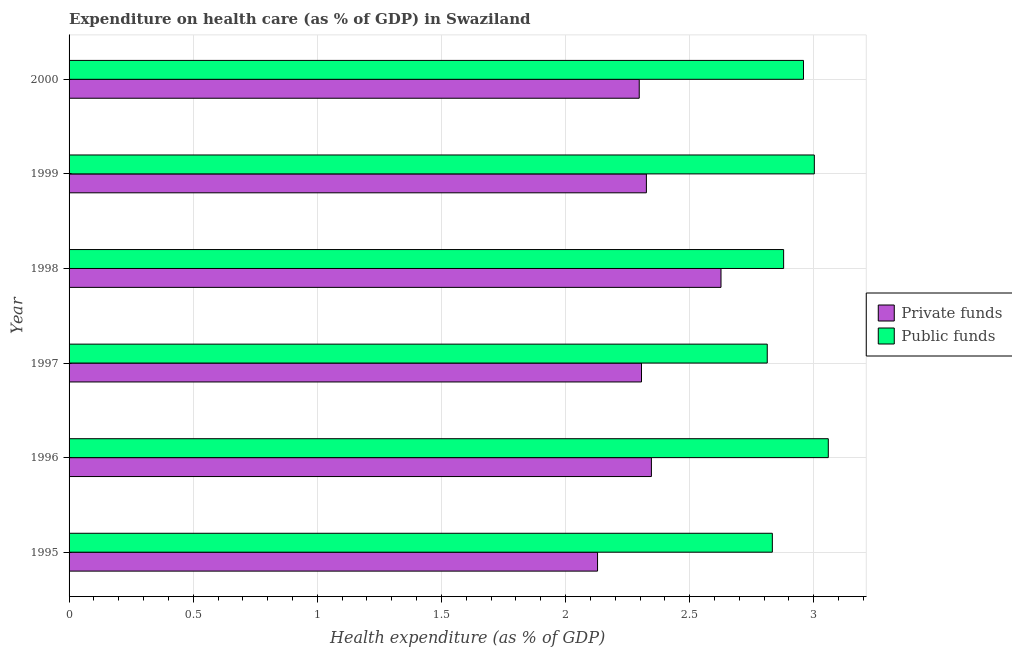Are the number of bars per tick equal to the number of legend labels?
Your response must be concise. Yes. Are the number of bars on each tick of the Y-axis equal?
Ensure brevity in your answer.  Yes. How many bars are there on the 5th tick from the bottom?
Ensure brevity in your answer.  2. What is the label of the 3rd group of bars from the top?
Your response must be concise. 1998. In how many cases, is the number of bars for a given year not equal to the number of legend labels?
Your response must be concise. 0. What is the amount of public funds spent in healthcare in 1998?
Offer a very short reply. 2.88. Across all years, what is the maximum amount of private funds spent in healthcare?
Provide a succinct answer. 2.63. Across all years, what is the minimum amount of public funds spent in healthcare?
Provide a succinct answer. 2.81. In which year was the amount of public funds spent in healthcare maximum?
Your response must be concise. 1996. In which year was the amount of public funds spent in healthcare minimum?
Provide a short and direct response. 1997. What is the total amount of public funds spent in healthcare in the graph?
Provide a short and direct response. 17.54. What is the difference between the amount of public funds spent in healthcare in 1997 and that in 2000?
Provide a short and direct response. -0.15. What is the difference between the amount of public funds spent in healthcare in 1995 and the amount of private funds spent in healthcare in 1998?
Your answer should be very brief. 0.21. What is the average amount of private funds spent in healthcare per year?
Provide a succinct answer. 2.34. In the year 2000, what is the difference between the amount of private funds spent in healthcare and amount of public funds spent in healthcare?
Offer a terse response. -0.66. In how many years, is the amount of public funds spent in healthcare greater than 2.8 %?
Your answer should be compact. 6. What is the ratio of the amount of public funds spent in healthcare in 1998 to that in 2000?
Provide a succinct answer. 0.97. What is the difference between the highest and the second highest amount of private funds spent in healthcare?
Offer a terse response. 0.28. In how many years, is the amount of public funds spent in healthcare greater than the average amount of public funds spent in healthcare taken over all years?
Ensure brevity in your answer.  3. Is the sum of the amount of public funds spent in healthcare in 1998 and 2000 greater than the maximum amount of private funds spent in healthcare across all years?
Offer a terse response. Yes. What does the 2nd bar from the top in 2000 represents?
Your response must be concise. Private funds. What does the 2nd bar from the bottom in 1999 represents?
Keep it short and to the point. Public funds. How many bars are there?
Your answer should be compact. 12. Are all the bars in the graph horizontal?
Provide a short and direct response. Yes. What is the difference between two consecutive major ticks on the X-axis?
Give a very brief answer. 0.5. Are the values on the major ticks of X-axis written in scientific E-notation?
Your answer should be very brief. No. Does the graph contain any zero values?
Make the answer very short. No. How are the legend labels stacked?
Your answer should be compact. Vertical. What is the title of the graph?
Your answer should be very brief. Expenditure on health care (as % of GDP) in Swaziland. What is the label or title of the X-axis?
Ensure brevity in your answer.  Health expenditure (as % of GDP). What is the Health expenditure (as % of GDP) in Private funds in 1995?
Offer a very short reply. 2.13. What is the Health expenditure (as % of GDP) of Public funds in 1995?
Give a very brief answer. 2.83. What is the Health expenditure (as % of GDP) in Private funds in 1996?
Your answer should be very brief. 2.35. What is the Health expenditure (as % of GDP) in Public funds in 1996?
Make the answer very short. 3.06. What is the Health expenditure (as % of GDP) in Private funds in 1997?
Make the answer very short. 2.31. What is the Health expenditure (as % of GDP) in Public funds in 1997?
Offer a terse response. 2.81. What is the Health expenditure (as % of GDP) of Private funds in 1998?
Your answer should be compact. 2.63. What is the Health expenditure (as % of GDP) of Public funds in 1998?
Provide a succinct answer. 2.88. What is the Health expenditure (as % of GDP) in Private funds in 1999?
Give a very brief answer. 2.33. What is the Health expenditure (as % of GDP) in Public funds in 1999?
Offer a very short reply. 3. What is the Health expenditure (as % of GDP) of Private funds in 2000?
Offer a terse response. 2.3. What is the Health expenditure (as % of GDP) of Public funds in 2000?
Offer a very short reply. 2.96. Across all years, what is the maximum Health expenditure (as % of GDP) of Private funds?
Your answer should be compact. 2.63. Across all years, what is the maximum Health expenditure (as % of GDP) in Public funds?
Offer a very short reply. 3.06. Across all years, what is the minimum Health expenditure (as % of GDP) in Private funds?
Keep it short and to the point. 2.13. Across all years, what is the minimum Health expenditure (as % of GDP) in Public funds?
Provide a succinct answer. 2.81. What is the total Health expenditure (as % of GDP) in Private funds in the graph?
Your answer should be very brief. 14.03. What is the total Health expenditure (as % of GDP) of Public funds in the graph?
Provide a succinct answer. 17.54. What is the difference between the Health expenditure (as % of GDP) of Private funds in 1995 and that in 1996?
Offer a very short reply. -0.22. What is the difference between the Health expenditure (as % of GDP) of Public funds in 1995 and that in 1996?
Give a very brief answer. -0.23. What is the difference between the Health expenditure (as % of GDP) of Private funds in 1995 and that in 1997?
Provide a succinct answer. -0.18. What is the difference between the Health expenditure (as % of GDP) in Public funds in 1995 and that in 1997?
Your response must be concise. 0.02. What is the difference between the Health expenditure (as % of GDP) of Private funds in 1995 and that in 1998?
Provide a succinct answer. -0.5. What is the difference between the Health expenditure (as % of GDP) of Public funds in 1995 and that in 1998?
Make the answer very short. -0.05. What is the difference between the Health expenditure (as % of GDP) of Private funds in 1995 and that in 1999?
Provide a short and direct response. -0.2. What is the difference between the Health expenditure (as % of GDP) in Public funds in 1995 and that in 1999?
Give a very brief answer. -0.17. What is the difference between the Health expenditure (as % of GDP) of Private funds in 1995 and that in 2000?
Provide a succinct answer. -0.17. What is the difference between the Health expenditure (as % of GDP) of Public funds in 1995 and that in 2000?
Ensure brevity in your answer.  -0.13. What is the difference between the Health expenditure (as % of GDP) of Private funds in 1996 and that in 1997?
Provide a succinct answer. 0.04. What is the difference between the Health expenditure (as % of GDP) of Public funds in 1996 and that in 1997?
Keep it short and to the point. 0.25. What is the difference between the Health expenditure (as % of GDP) of Private funds in 1996 and that in 1998?
Make the answer very short. -0.28. What is the difference between the Health expenditure (as % of GDP) of Public funds in 1996 and that in 1998?
Make the answer very short. 0.18. What is the difference between the Health expenditure (as % of GDP) in Private funds in 1996 and that in 1999?
Your answer should be compact. 0.02. What is the difference between the Health expenditure (as % of GDP) in Public funds in 1996 and that in 1999?
Ensure brevity in your answer.  0.06. What is the difference between the Health expenditure (as % of GDP) of Private funds in 1996 and that in 2000?
Your response must be concise. 0.05. What is the difference between the Health expenditure (as % of GDP) in Private funds in 1997 and that in 1998?
Your answer should be very brief. -0.32. What is the difference between the Health expenditure (as % of GDP) of Public funds in 1997 and that in 1998?
Ensure brevity in your answer.  -0.07. What is the difference between the Health expenditure (as % of GDP) of Private funds in 1997 and that in 1999?
Keep it short and to the point. -0.02. What is the difference between the Health expenditure (as % of GDP) of Public funds in 1997 and that in 1999?
Your answer should be compact. -0.19. What is the difference between the Health expenditure (as % of GDP) of Private funds in 1997 and that in 2000?
Provide a short and direct response. 0.01. What is the difference between the Health expenditure (as % of GDP) of Public funds in 1997 and that in 2000?
Provide a short and direct response. -0.15. What is the difference between the Health expenditure (as % of GDP) of Private funds in 1998 and that in 1999?
Your response must be concise. 0.3. What is the difference between the Health expenditure (as % of GDP) of Public funds in 1998 and that in 1999?
Offer a terse response. -0.12. What is the difference between the Health expenditure (as % of GDP) in Private funds in 1998 and that in 2000?
Provide a short and direct response. 0.33. What is the difference between the Health expenditure (as % of GDP) of Public funds in 1998 and that in 2000?
Offer a very short reply. -0.08. What is the difference between the Health expenditure (as % of GDP) in Private funds in 1999 and that in 2000?
Your response must be concise. 0.03. What is the difference between the Health expenditure (as % of GDP) of Public funds in 1999 and that in 2000?
Offer a very short reply. 0.04. What is the difference between the Health expenditure (as % of GDP) in Private funds in 1995 and the Health expenditure (as % of GDP) in Public funds in 1996?
Offer a terse response. -0.93. What is the difference between the Health expenditure (as % of GDP) in Private funds in 1995 and the Health expenditure (as % of GDP) in Public funds in 1997?
Offer a terse response. -0.68. What is the difference between the Health expenditure (as % of GDP) of Private funds in 1995 and the Health expenditure (as % of GDP) of Public funds in 1998?
Your answer should be compact. -0.75. What is the difference between the Health expenditure (as % of GDP) in Private funds in 1995 and the Health expenditure (as % of GDP) in Public funds in 1999?
Make the answer very short. -0.87. What is the difference between the Health expenditure (as % of GDP) of Private funds in 1995 and the Health expenditure (as % of GDP) of Public funds in 2000?
Keep it short and to the point. -0.83. What is the difference between the Health expenditure (as % of GDP) of Private funds in 1996 and the Health expenditure (as % of GDP) of Public funds in 1997?
Offer a very short reply. -0.47. What is the difference between the Health expenditure (as % of GDP) in Private funds in 1996 and the Health expenditure (as % of GDP) in Public funds in 1998?
Your answer should be very brief. -0.53. What is the difference between the Health expenditure (as % of GDP) of Private funds in 1996 and the Health expenditure (as % of GDP) of Public funds in 1999?
Give a very brief answer. -0.66. What is the difference between the Health expenditure (as % of GDP) of Private funds in 1996 and the Health expenditure (as % of GDP) of Public funds in 2000?
Offer a very short reply. -0.61. What is the difference between the Health expenditure (as % of GDP) of Private funds in 1997 and the Health expenditure (as % of GDP) of Public funds in 1998?
Your response must be concise. -0.57. What is the difference between the Health expenditure (as % of GDP) in Private funds in 1997 and the Health expenditure (as % of GDP) in Public funds in 1999?
Offer a very short reply. -0.7. What is the difference between the Health expenditure (as % of GDP) of Private funds in 1997 and the Health expenditure (as % of GDP) of Public funds in 2000?
Give a very brief answer. -0.65. What is the difference between the Health expenditure (as % of GDP) of Private funds in 1998 and the Health expenditure (as % of GDP) of Public funds in 1999?
Your response must be concise. -0.38. What is the difference between the Health expenditure (as % of GDP) of Private funds in 1998 and the Health expenditure (as % of GDP) of Public funds in 2000?
Your answer should be very brief. -0.33. What is the difference between the Health expenditure (as % of GDP) of Private funds in 1999 and the Health expenditure (as % of GDP) of Public funds in 2000?
Offer a terse response. -0.63. What is the average Health expenditure (as % of GDP) in Private funds per year?
Keep it short and to the point. 2.34. What is the average Health expenditure (as % of GDP) in Public funds per year?
Give a very brief answer. 2.92. In the year 1995, what is the difference between the Health expenditure (as % of GDP) of Private funds and Health expenditure (as % of GDP) of Public funds?
Offer a very short reply. -0.7. In the year 1996, what is the difference between the Health expenditure (as % of GDP) in Private funds and Health expenditure (as % of GDP) in Public funds?
Your answer should be compact. -0.71. In the year 1997, what is the difference between the Health expenditure (as % of GDP) of Private funds and Health expenditure (as % of GDP) of Public funds?
Provide a succinct answer. -0.51. In the year 1998, what is the difference between the Health expenditure (as % of GDP) in Private funds and Health expenditure (as % of GDP) in Public funds?
Keep it short and to the point. -0.25. In the year 1999, what is the difference between the Health expenditure (as % of GDP) of Private funds and Health expenditure (as % of GDP) of Public funds?
Make the answer very short. -0.68. In the year 2000, what is the difference between the Health expenditure (as % of GDP) in Private funds and Health expenditure (as % of GDP) in Public funds?
Your response must be concise. -0.66. What is the ratio of the Health expenditure (as % of GDP) in Private funds in 1995 to that in 1996?
Your answer should be compact. 0.91. What is the ratio of the Health expenditure (as % of GDP) of Public funds in 1995 to that in 1996?
Offer a very short reply. 0.93. What is the ratio of the Health expenditure (as % of GDP) of Private funds in 1995 to that in 1997?
Your answer should be compact. 0.92. What is the ratio of the Health expenditure (as % of GDP) of Public funds in 1995 to that in 1997?
Offer a very short reply. 1.01. What is the ratio of the Health expenditure (as % of GDP) of Private funds in 1995 to that in 1998?
Your answer should be very brief. 0.81. What is the ratio of the Health expenditure (as % of GDP) of Public funds in 1995 to that in 1998?
Provide a succinct answer. 0.98. What is the ratio of the Health expenditure (as % of GDP) of Private funds in 1995 to that in 1999?
Keep it short and to the point. 0.92. What is the ratio of the Health expenditure (as % of GDP) in Public funds in 1995 to that in 1999?
Give a very brief answer. 0.94. What is the ratio of the Health expenditure (as % of GDP) in Private funds in 1995 to that in 2000?
Make the answer very short. 0.93. What is the ratio of the Health expenditure (as % of GDP) of Public funds in 1995 to that in 2000?
Ensure brevity in your answer.  0.96. What is the ratio of the Health expenditure (as % of GDP) of Private funds in 1996 to that in 1997?
Make the answer very short. 1.02. What is the ratio of the Health expenditure (as % of GDP) of Public funds in 1996 to that in 1997?
Your response must be concise. 1.09. What is the ratio of the Health expenditure (as % of GDP) of Private funds in 1996 to that in 1998?
Provide a succinct answer. 0.89. What is the ratio of the Health expenditure (as % of GDP) in Public funds in 1996 to that in 1998?
Your answer should be compact. 1.06. What is the ratio of the Health expenditure (as % of GDP) of Private funds in 1996 to that in 1999?
Make the answer very short. 1.01. What is the ratio of the Health expenditure (as % of GDP) of Public funds in 1996 to that in 1999?
Give a very brief answer. 1.02. What is the ratio of the Health expenditure (as % of GDP) of Private funds in 1996 to that in 2000?
Ensure brevity in your answer.  1.02. What is the ratio of the Health expenditure (as % of GDP) in Public funds in 1996 to that in 2000?
Provide a succinct answer. 1.03. What is the ratio of the Health expenditure (as % of GDP) of Private funds in 1997 to that in 1998?
Provide a short and direct response. 0.88. What is the ratio of the Health expenditure (as % of GDP) of Public funds in 1997 to that in 1998?
Offer a terse response. 0.98. What is the ratio of the Health expenditure (as % of GDP) of Private funds in 1997 to that in 1999?
Your answer should be very brief. 0.99. What is the ratio of the Health expenditure (as % of GDP) in Public funds in 1997 to that in 1999?
Ensure brevity in your answer.  0.94. What is the ratio of the Health expenditure (as % of GDP) in Public funds in 1997 to that in 2000?
Provide a succinct answer. 0.95. What is the ratio of the Health expenditure (as % of GDP) of Private funds in 1998 to that in 1999?
Your response must be concise. 1.13. What is the ratio of the Health expenditure (as % of GDP) of Public funds in 1998 to that in 1999?
Ensure brevity in your answer.  0.96. What is the ratio of the Health expenditure (as % of GDP) in Private funds in 1998 to that in 2000?
Keep it short and to the point. 1.14. What is the ratio of the Health expenditure (as % of GDP) in Public funds in 1998 to that in 2000?
Offer a terse response. 0.97. What is the ratio of the Health expenditure (as % of GDP) of Private funds in 1999 to that in 2000?
Your answer should be very brief. 1.01. What is the ratio of the Health expenditure (as % of GDP) in Public funds in 1999 to that in 2000?
Make the answer very short. 1.01. What is the difference between the highest and the second highest Health expenditure (as % of GDP) of Private funds?
Your answer should be compact. 0.28. What is the difference between the highest and the second highest Health expenditure (as % of GDP) in Public funds?
Offer a terse response. 0.06. What is the difference between the highest and the lowest Health expenditure (as % of GDP) in Private funds?
Keep it short and to the point. 0.5. What is the difference between the highest and the lowest Health expenditure (as % of GDP) in Public funds?
Make the answer very short. 0.25. 